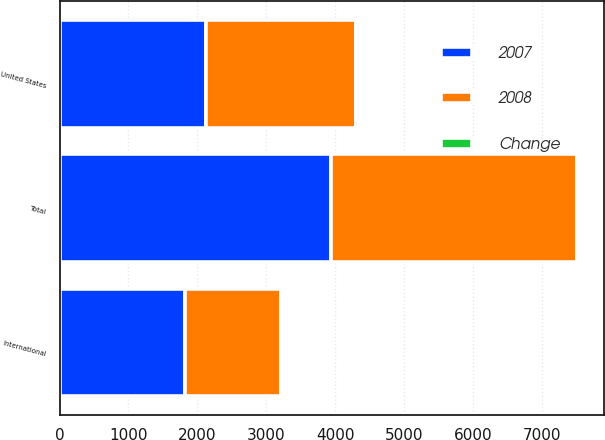<chart> <loc_0><loc_0><loc_500><loc_500><stacked_bar_chart><ecel><fcel>United States<fcel>International<fcel>Total<nl><fcel>2007<fcel>2130<fcel>1817<fcel>3947<nl><fcel>2008<fcel>2175<fcel>1397<fcel>3572<nl><fcel>Change<fcel>2.1<fcel>30.1<fcel>10.5<nl></chart> 